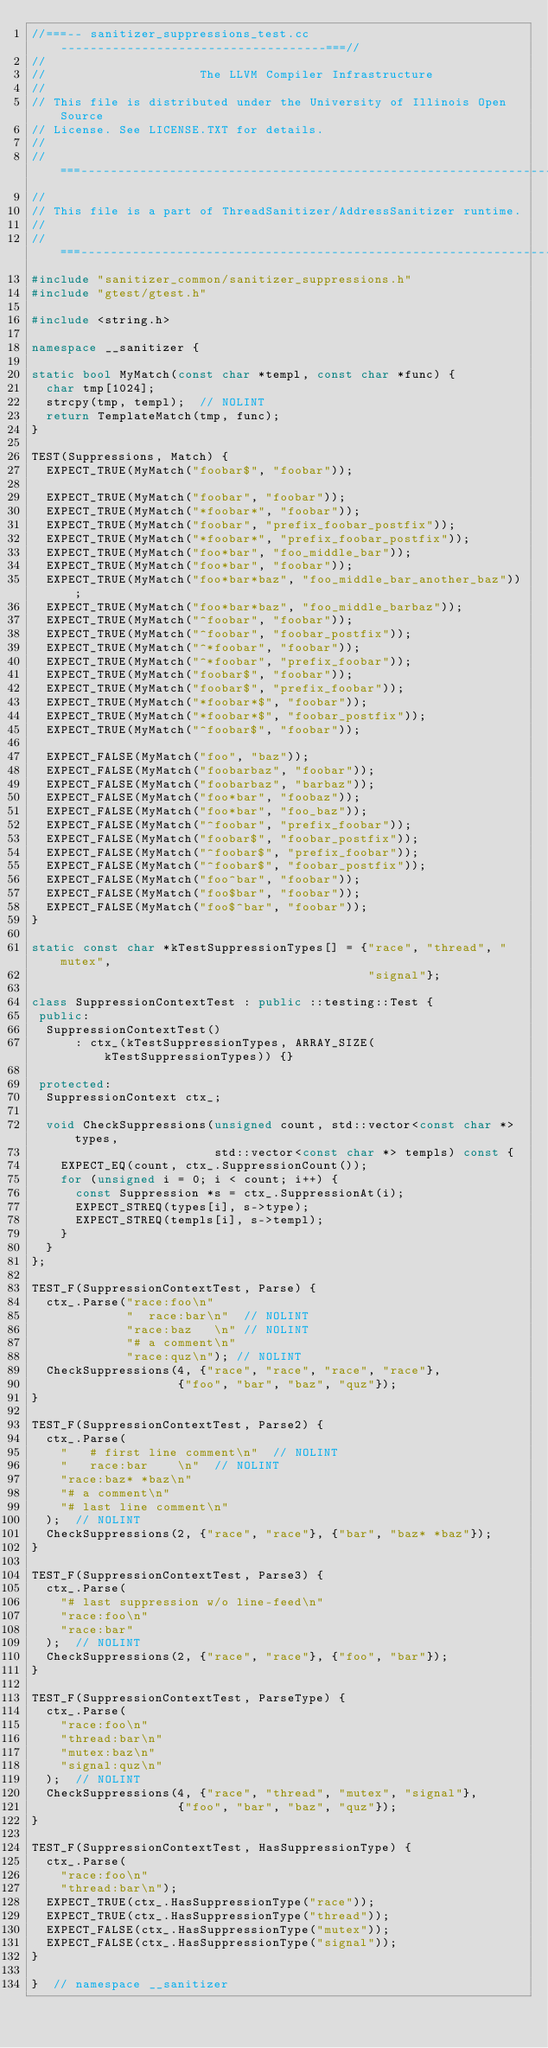Convert code to text. <code><loc_0><loc_0><loc_500><loc_500><_C++_>//===-- sanitizer_suppressions_test.cc ------------------------------------===//
//
//                     The LLVM Compiler Infrastructure
//
// This file is distributed under the University of Illinois Open Source
// License. See LICENSE.TXT for details.
//
//===----------------------------------------------------------------------===//
//
// This file is a part of ThreadSanitizer/AddressSanitizer runtime.
//
//===----------------------------------------------------------------------===//
#include "sanitizer_common/sanitizer_suppressions.h"
#include "gtest/gtest.h"

#include <string.h>

namespace __sanitizer {

static bool MyMatch(const char *templ, const char *func) {
  char tmp[1024];
  strcpy(tmp, templ);  // NOLINT
  return TemplateMatch(tmp, func);
}

TEST(Suppressions, Match) {
  EXPECT_TRUE(MyMatch("foobar$", "foobar"));

  EXPECT_TRUE(MyMatch("foobar", "foobar"));
  EXPECT_TRUE(MyMatch("*foobar*", "foobar"));
  EXPECT_TRUE(MyMatch("foobar", "prefix_foobar_postfix"));
  EXPECT_TRUE(MyMatch("*foobar*", "prefix_foobar_postfix"));
  EXPECT_TRUE(MyMatch("foo*bar", "foo_middle_bar"));
  EXPECT_TRUE(MyMatch("foo*bar", "foobar"));
  EXPECT_TRUE(MyMatch("foo*bar*baz", "foo_middle_bar_another_baz"));
  EXPECT_TRUE(MyMatch("foo*bar*baz", "foo_middle_barbaz"));
  EXPECT_TRUE(MyMatch("^foobar", "foobar"));
  EXPECT_TRUE(MyMatch("^foobar", "foobar_postfix"));
  EXPECT_TRUE(MyMatch("^*foobar", "foobar"));
  EXPECT_TRUE(MyMatch("^*foobar", "prefix_foobar"));
  EXPECT_TRUE(MyMatch("foobar$", "foobar"));
  EXPECT_TRUE(MyMatch("foobar$", "prefix_foobar"));
  EXPECT_TRUE(MyMatch("*foobar*$", "foobar"));
  EXPECT_TRUE(MyMatch("*foobar*$", "foobar_postfix"));
  EXPECT_TRUE(MyMatch("^foobar$", "foobar"));

  EXPECT_FALSE(MyMatch("foo", "baz"));
  EXPECT_FALSE(MyMatch("foobarbaz", "foobar"));
  EXPECT_FALSE(MyMatch("foobarbaz", "barbaz"));
  EXPECT_FALSE(MyMatch("foo*bar", "foobaz"));
  EXPECT_FALSE(MyMatch("foo*bar", "foo_baz"));
  EXPECT_FALSE(MyMatch("^foobar", "prefix_foobar"));
  EXPECT_FALSE(MyMatch("foobar$", "foobar_postfix"));
  EXPECT_FALSE(MyMatch("^foobar$", "prefix_foobar"));
  EXPECT_FALSE(MyMatch("^foobar$", "foobar_postfix"));
  EXPECT_FALSE(MyMatch("foo^bar", "foobar"));
  EXPECT_FALSE(MyMatch("foo$bar", "foobar"));
  EXPECT_FALSE(MyMatch("foo$^bar", "foobar"));
}

static const char *kTestSuppressionTypes[] = {"race", "thread", "mutex",
                                              "signal"};

class SuppressionContextTest : public ::testing::Test {
 public:
  SuppressionContextTest()
      : ctx_(kTestSuppressionTypes, ARRAY_SIZE(kTestSuppressionTypes)) {}

 protected:
  SuppressionContext ctx_;

  void CheckSuppressions(unsigned count, std::vector<const char *> types,
                         std::vector<const char *> templs) const {
    EXPECT_EQ(count, ctx_.SuppressionCount());
    for (unsigned i = 0; i < count; i++) {
      const Suppression *s = ctx_.SuppressionAt(i);
      EXPECT_STREQ(types[i], s->type);
      EXPECT_STREQ(templs[i], s->templ);
    }
  }
};

TEST_F(SuppressionContextTest, Parse) {
  ctx_.Parse("race:foo\n"
             " 	race:bar\n"  // NOLINT
             "race:baz	 \n" // NOLINT
             "# a comment\n"
             "race:quz\n"); // NOLINT
  CheckSuppressions(4, {"race", "race", "race", "race"},
                    {"foo", "bar", "baz", "quz"});
}

TEST_F(SuppressionContextTest, Parse2) {
  ctx_.Parse(
    "  	# first line comment\n"  // NOLINT
    " 	race:bar 	\n"  // NOLINT
    "race:baz* *baz\n"
    "# a comment\n"
    "# last line comment\n"
  );  // NOLINT
  CheckSuppressions(2, {"race", "race"}, {"bar", "baz* *baz"});
}

TEST_F(SuppressionContextTest, Parse3) {
  ctx_.Parse(
    "# last suppression w/o line-feed\n"
    "race:foo\n"
    "race:bar"
  );  // NOLINT
  CheckSuppressions(2, {"race", "race"}, {"foo", "bar"});
}

TEST_F(SuppressionContextTest, ParseType) {
  ctx_.Parse(
    "race:foo\n"
    "thread:bar\n"
    "mutex:baz\n"
    "signal:quz\n"
  );  // NOLINT
  CheckSuppressions(4, {"race", "thread", "mutex", "signal"},
                    {"foo", "bar", "baz", "quz"});
}

TEST_F(SuppressionContextTest, HasSuppressionType) {
  ctx_.Parse(
    "race:foo\n"
    "thread:bar\n");
  EXPECT_TRUE(ctx_.HasSuppressionType("race"));
  EXPECT_TRUE(ctx_.HasSuppressionType("thread"));
  EXPECT_FALSE(ctx_.HasSuppressionType("mutex"));
  EXPECT_FALSE(ctx_.HasSuppressionType("signal"));
}

}  // namespace __sanitizer
</code> 